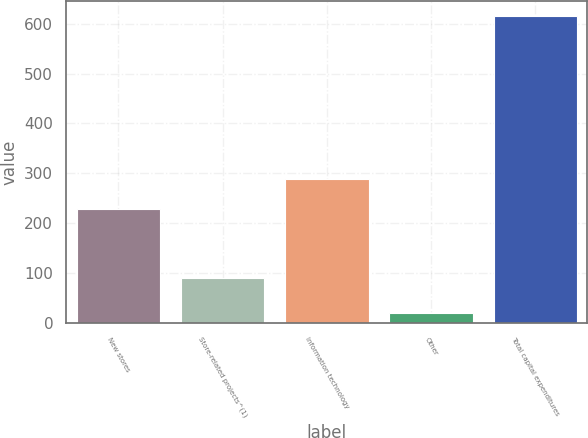Convert chart to OTSL. <chart><loc_0><loc_0><loc_500><loc_500><bar_chart><fcel>New stores<fcel>Store-related projects^(1)<fcel>Information technology<fcel>Other<fcel>Total capital expenditures<nl><fcel>229<fcel>90<fcel>288.4<fcel>21<fcel>615<nl></chart> 